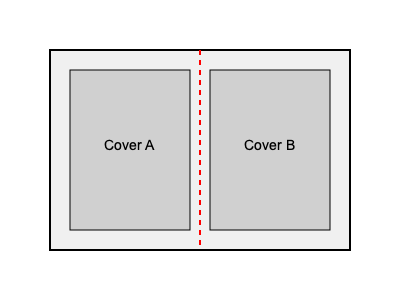Analyzing the book cover designs shown above, which design principle is most prominently demonstrated, and how might this influence a potential bestseller's visual appeal? To answer this question, let's analyze the book cover designs step-by-step:

1. Observation: The image shows two book cover designs (Cover A and Cover B) side by side within a larger rectangle.

2. Symmetry: There's a red dashed line running vertically through the center of the image, dividing it into two equal halves.

3. Balance: Both Cover A and Cover B are of equal size and placed equidistant from the central line.

4. Design Principle: The most prominent design principle demonstrated here is symmetry and balance.

5. Symmetrical Balance: This type of balance is achieved when elements on both sides of a central axis are identical or very similar in terms of size, shape, and placement.

6. Visual Appeal: Symmetry often creates a sense of order, stability, and professionalism, which can be appealing to readers.

7. Bestseller Influence: For a potential bestseller, this balanced and symmetrical design could:
   a) Create a strong, memorable visual identity
   b) Convey a sense of reliability and quality
   c) Appeal to a wide audience due to its clean, organized appearance

8. Publisher Perspective: As a publisher representative, recognizing the power of symmetry in cover design could inform decisions about visual branding for classified stories being adapted into books.

Therefore, the most prominently demonstrated design principle is symmetrical balance, which can significantly enhance a potential bestseller's visual appeal through its organized and professional appearance.
Answer: Symmetrical balance, enhancing appeal through organized, professional appearance 